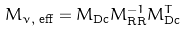<formula> <loc_0><loc_0><loc_500><loc_500>M _ { \nu , \text { eff} } = M _ { \text {Dc} } M _ { \text {RR} } ^ { - 1 } M _ { \text {Dc} } ^ { T }</formula> 